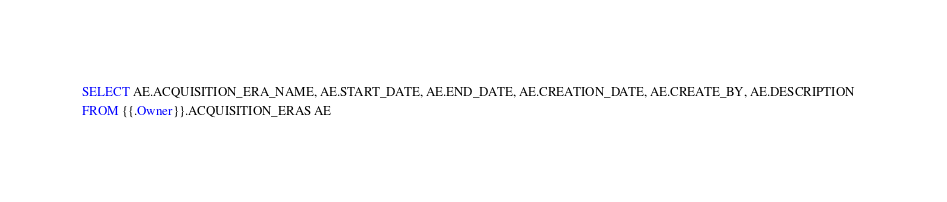<code> <loc_0><loc_0><loc_500><loc_500><_SQL_>SELECT AE.ACQUISITION_ERA_NAME, AE.START_DATE, AE.END_DATE, AE.CREATION_DATE, AE.CREATE_BY, AE.DESCRIPTION   
FROM {{.Owner}}.ACQUISITION_ERAS AE
</code> 